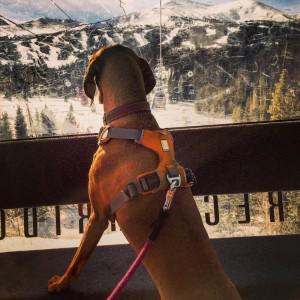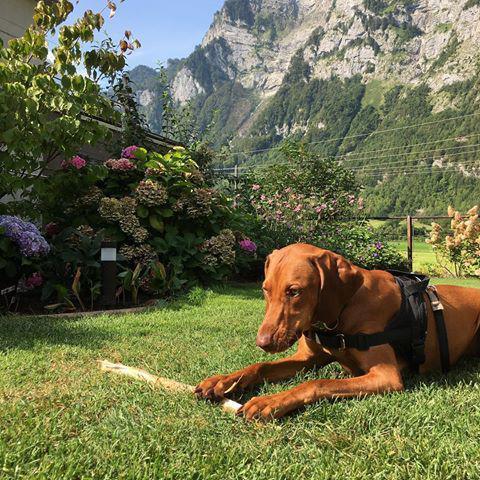The first image is the image on the left, the second image is the image on the right. For the images shown, is this caption "The left image shows a dog with its front paws propped up, gazing toward a scenic view away from the camera, and the right image features purple flowers behind one dog." true? Answer yes or no. Yes. The first image is the image on the left, the second image is the image on the right. Examine the images to the left and right. Is the description "In one image, a tan dog is standing upright with its front feet on a raised area before it, the back of its head visible as it looks away." accurate? Answer yes or no. Yes. 